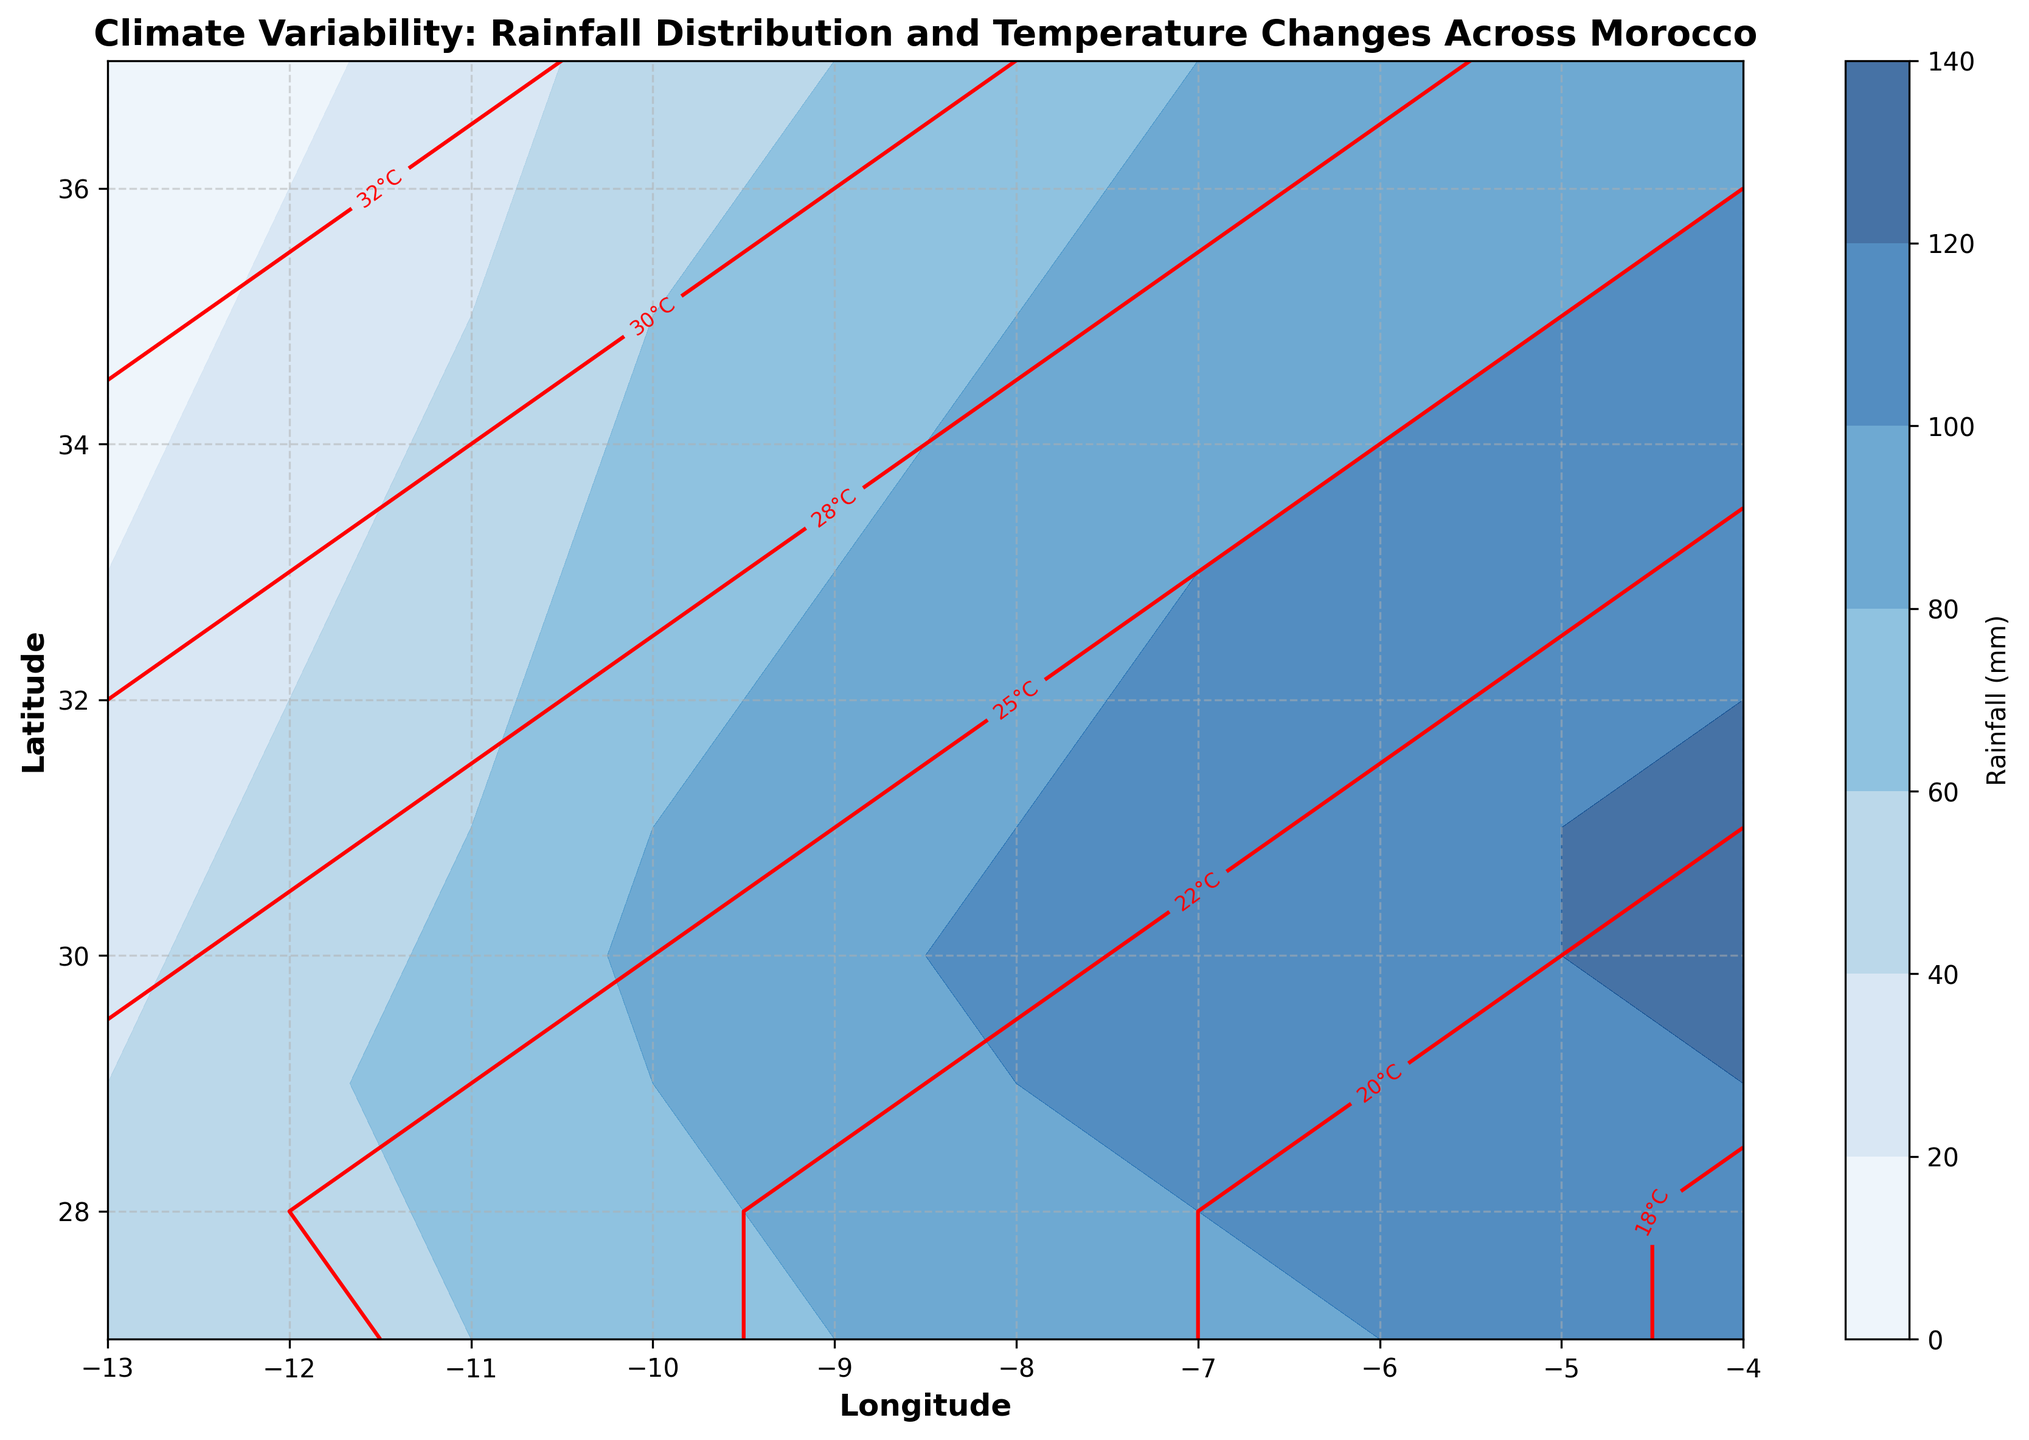What's the overall trend in rainfall distribution from south to north Morocco? By examining the contour plot, the rainfall distribution generally increases from the south (lower latitudes) to the north (higher latitudes). This is indicated by the progressively darker shades of blue as one moves from bottom to top.
Answer: Increasing What is the temperature range across Morocco? The contour labels indicate that temperatures range from around 17°C to 35°C across Morocco. The warmer temperatures are associated with lower latitudes, while cooler temperatures are found at higher latitudes.
Answer: 17°C to 35°C At which longitude is the highest amount of rainfall recorded? By observing the contour plot, the darkest blue shade, indicating the highest rainfall, is seen around longitude -4.0 across various latitudes.
Answer: -4.0 How do rainfall and temperature patterns correlate across the different regions? The contour plot shows that areas with higher rainfall (darker blue) generally correspond to lower temperatures (red contour lines with lower values), suggesting an inverse relationship between rainfall and temperature across Morocco.
Answer: Inverse relationship Which latitude shows the maximum difference in rainfall levels? By examining the contour plot, latitude 31.0 shows the maximum difference, with rainfall levels ranging from 30 mm (at longitude -13.0) to 125 mm (at longitude -4.0).
Answer: 31.0 Comparing longitude -8.0, does the rainfall trend increase or decrease from latitude 27.0 to latitude 37.0? Observing the blue shades at longitude -8.0, the rainfall trend increases as one moves from latitude 27.0 (around 85 mm) to latitude 37.0 (around 75 mm).
Answer: Increase Between latitudes 32.0 and 35.0, which latitude registers the highest temperature at longitude -11.0? By examining the red contour lines, at longitude -11.0, latitude 35.0 registers the highest temperature, indicated by the 31°C label, as compared to the other latitudes.
Answer: 35.0 How does the temperature change along longitude -6.0 from latitude 27.0 to 37.0? The contour labels show temperature decreasing from around 19°C at latitude 27.0 to around 26°C at latitude 37.0 along longitude -6.0.
Answer: Decrease Is there any latitude where both rainfall and temperature values remain constant across different longitudes? By examining the contours, no such latitude exists where both rainfall (blue shades) and temperature (red lines) remain constant across all longitudes. Both parameters show variability.
Answer: No 